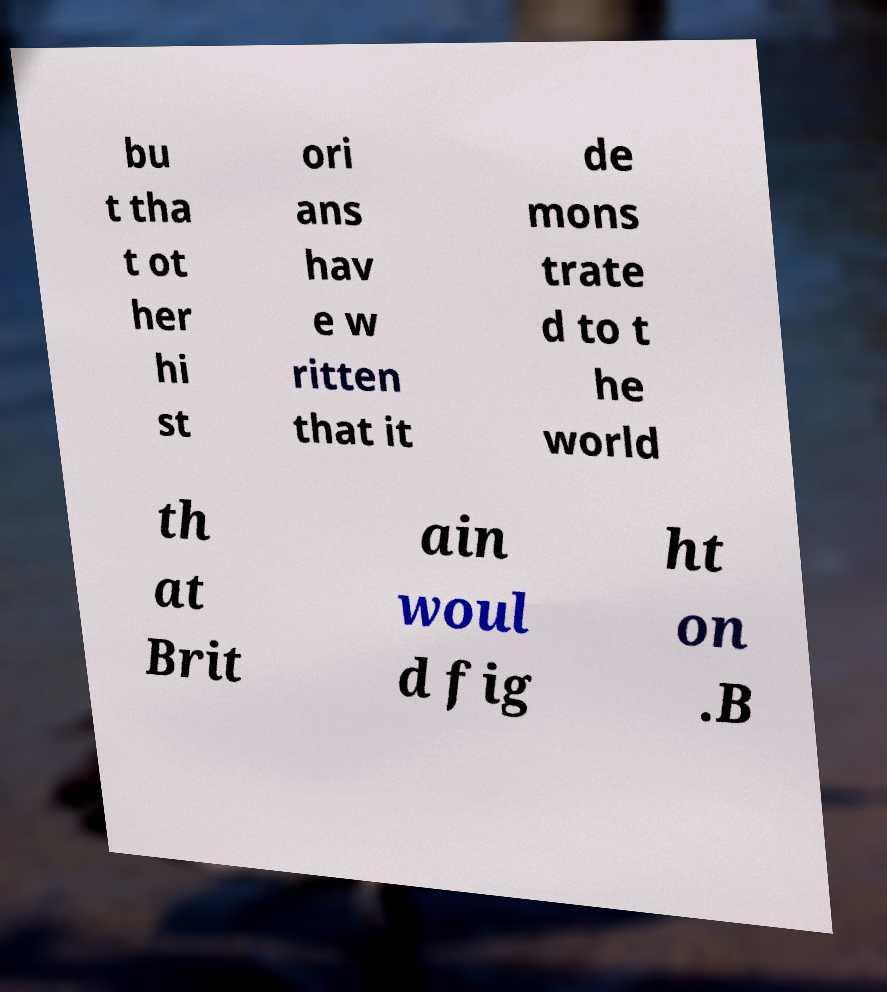I need the written content from this picture converted into text. Can you do that? bu t tha t ot her hi st ori ans hav e w ritten that it de mons trate d to t he world th at Brit ain woul d fig ht on .B 